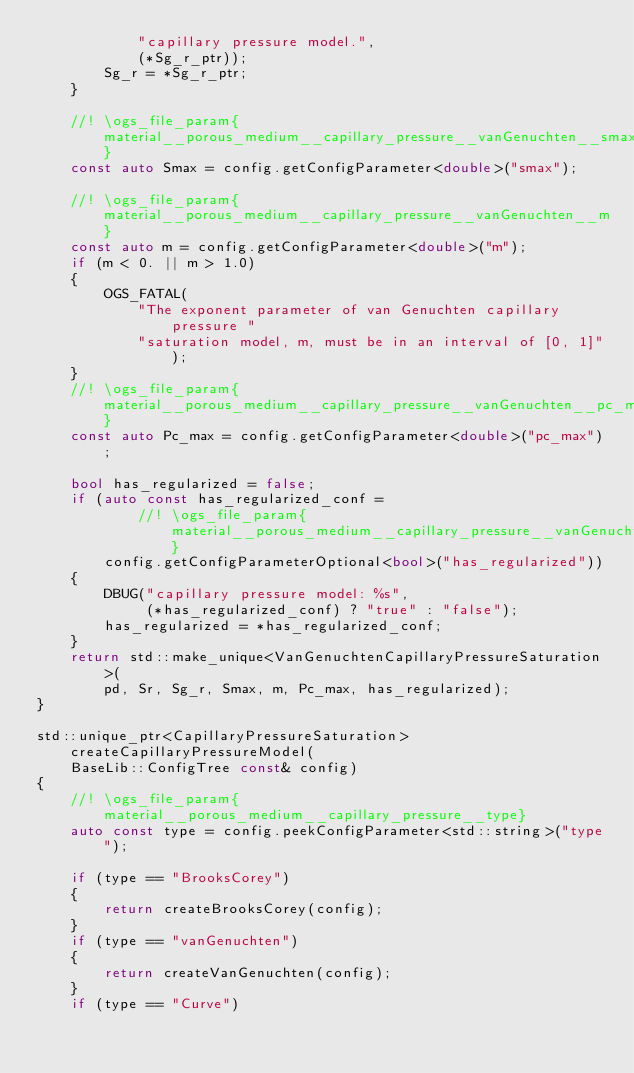Convert code to text. <code><loc_0><loc_0><loc_500><loc_500><_C++_>            "capillary pressure model.",
            (*Sg_r_ptr));
        Sg_r = *Sg_r_ptr;
    }

    //! \ogs_file_param{material__porous_medium__capillary_pressure__vanGenuchten__smax}
    const auto Smax = config.getConfigParameter<double>("smax");

    //! \ogs_file_param{material__porous_medium__capillary_pressure__vanGenuchten__m}
    const auto m = config.getConfigParameter<double>("m");
    if (m < 0. || m > 1.0)
    {
        OGS_FATAL(
            "The exponent parameter of van Genuchten capillary pressure "
            "saturation model, m, must be in an interval of [0, 1]");
    }
    //! \ogs_file_param{material__porous_medium__capillary_pressure__vanGenuchten__pc_max}
    const auto Pc_max = config.getConfigParameter<double>("pc_max");

    bool has_regularized = false;
    if (auto const has_regularized_conf =
            //! \ogs_file_param{material__porous_medium__capillary_pressure__vanGenuchten__has_regularized}
        config.getConfigParameterOptional<bool>("has_regularized"))
    {
        DBUG("capillary pressure model: %s",
             (*has_regularized_conf) ? "true" : "false");
        has_regularized = *has_regularized_conf;
    }
    return std::make_unique<VanGenuchtenCapillaryPressureSaturation>(
        pd, Sr, Sg_r, Smax, m, Pc_max, has_regularized);
}

std::unique_ptr<CapillaryPressureSaturation> createCapillaryPressureModel(
    BaseLib::ConfigTree const& config)
{
    //! \ogs_file_param{material__porous_medium__capillary_pressure__type}
    auto const type = config.peekConfigParameter<std::string>("type");

    if (type == "BrooksCorey")
    {
        return createBrooksCorey(config);
    }
    if (type == "vanGenuchten")
    {
        return createVanGenuchten(config);
    }
    if (type == "Curve")</code> 